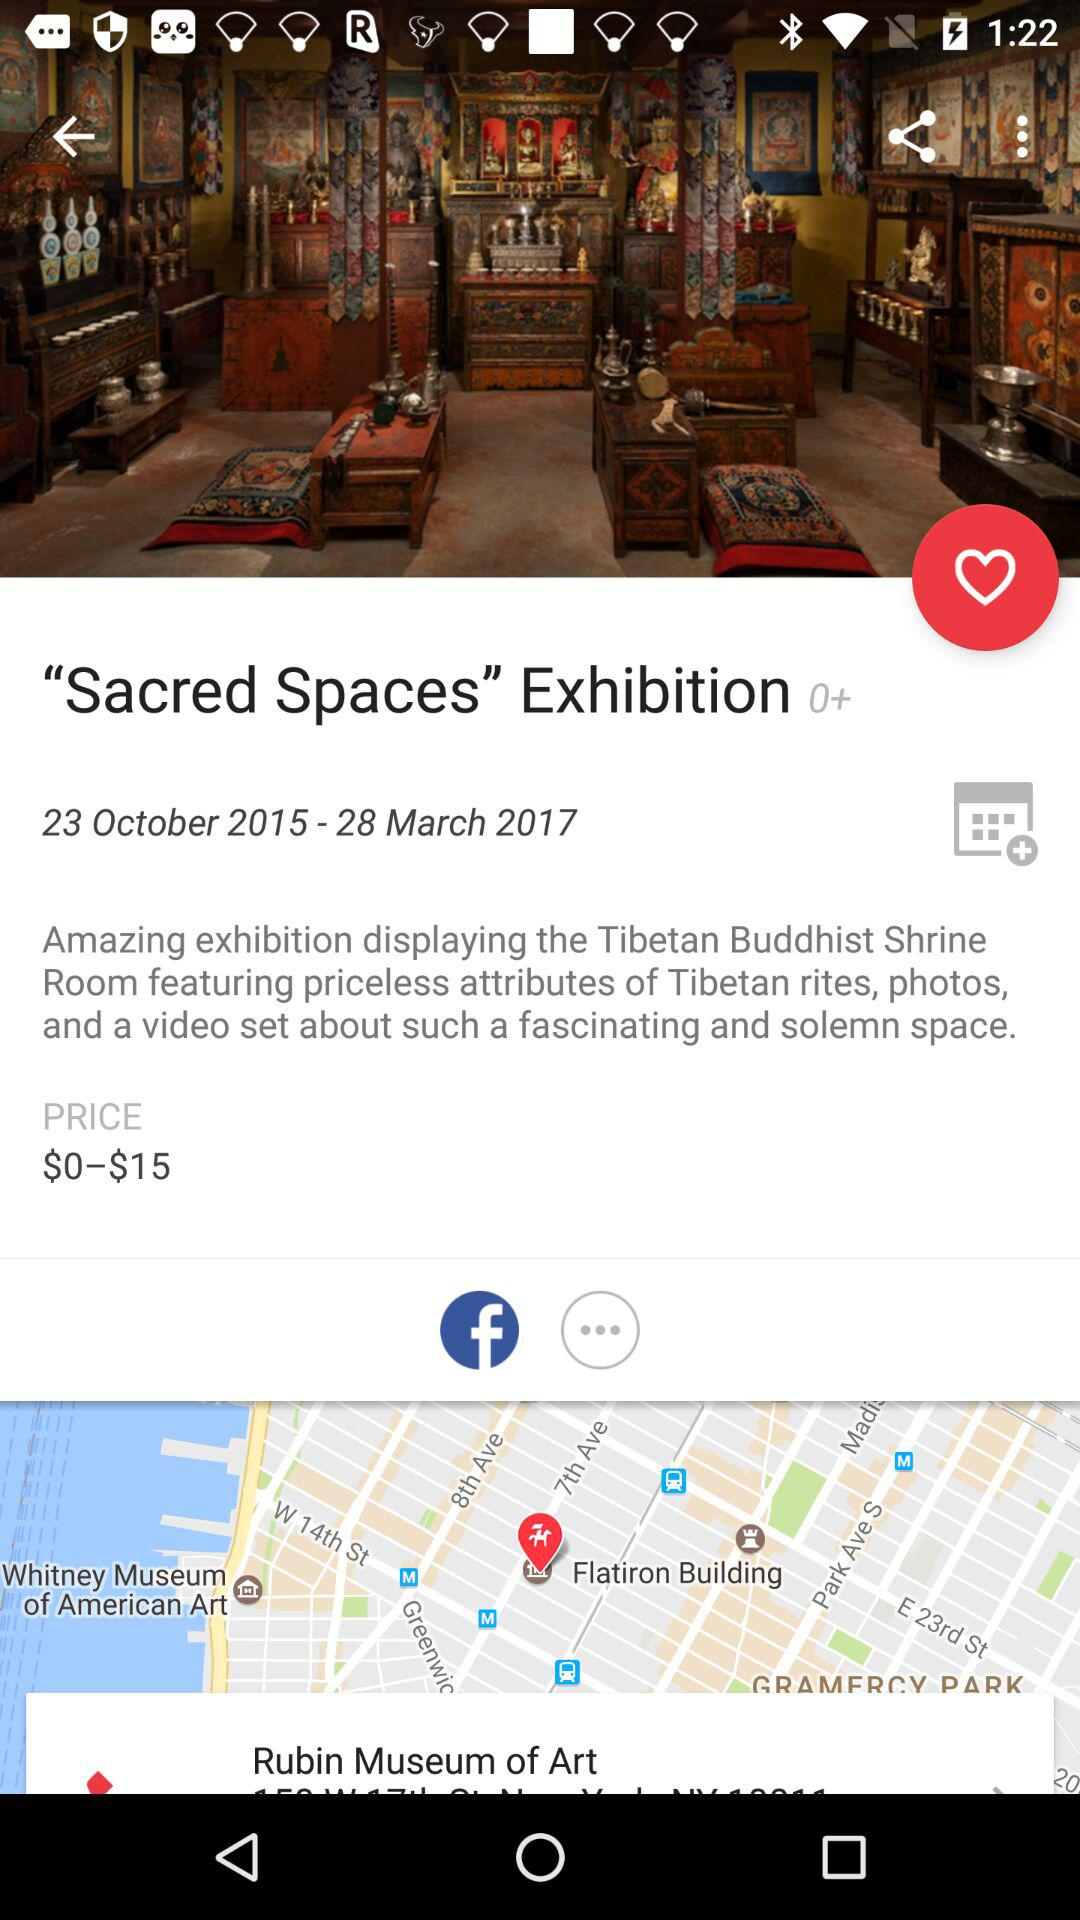Through what applications can users share? The application is Facebook. 